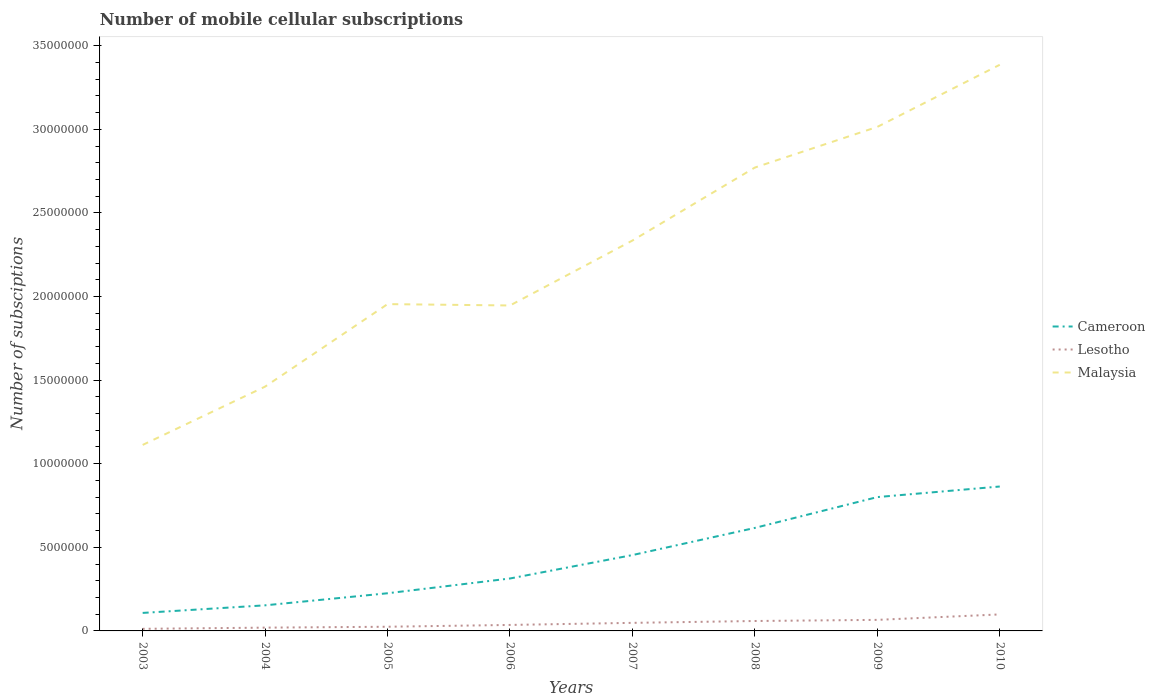How many different coloured lines are there?
Offer a very short reply. 3. Does the line corresponding to Malaysia intersect with the line corresponding to Lesotho?
Your response must be concise. No. Across all years, what is the maximum number of mobile cellular subscriptions in Lesotho?
Offer a terse response. 1.26e+05. What is the total number of mobile cellular subscriptions in Cameroon in the graph?
Provide a succinct answer. -5.08e+06. What is the difference between the highest and the second highest number of mobile cellular subscriptions in Cameroon?
Keep it short and to the point. 7.56e+06. What is the difference between the highest and the lowest number of mobile cellular subscriptions in Cameroon?
Give a very brief answer. 4. Are the values on the major ticks of Y-axis written in scientific E-notation?
Make the answer very short. No. Does the graph contain any zero values?
Offer a very short reply. No. What is the title of the graph?
Provide a succinct answer. Number of mobile cellular subscriptions. Does "Mongolia" appear as one of the legend labels in the graph?
Make the answer very short. No. What is the label or title of the Y-axis?
Offer a terse response. Number of subsciptions. What is the Number of subsciptions in Cameroon in 2003?
Provide a short and direct response. 1.08e+06. What is the Number of subsciptions of Lesotho in 2003?
Provide a short and direct response. 1.26e+05. What is the Number of subsciptions of Malaysia in 2003?
Give a very brief answer. 1.11e+07. What is the Number of subsciptions in Cameroon in 2004?
Keep it short and to the point. 1.53e+06. What is the Number of subsciptions in Lesotho in 2004?
Your answer should be compact. 1.96e+05. What is the Number of subsciptions of Malaysia in 2004?
Your answer should be compact. 1.46e+07. What is the Number of subsciptions of Cameroon in 2005?
Give a very brief answer. 2.25e+06. What is the Number of subsciptions in Lesotho in 2005?
Your answer should be very brief. 2.50e+05. What is the Number of subsciptions in Malaysia in 2005?
Make the answer very short. 1.95e+07. What is the Number of subsciptions in Cameroon in 2006?
Provide a short and direct response. 3.14e+06. What is the Number of subsciptions in Lesotho in 2006?
Offer a terse response. 3.58e+05. What is the Number of subsciptions in Malaysia in 2006?
Your answer should be compact. 1.95e+07. What is the Number of subsciptions of Cameroon in 2007?
Offer a terse response. 4.54e+06. What is the Number of subsciptions of Lesotho in 2007?
Your answer should be compact. 4.82e+05. What is the Number of subsciptions in Malaysia in 2007?
Keep it short and to the point. 2.33e+07. What is the Number of subsciptions in Cameroon in 2008?
Give a very brief answer. 6.16e+06. What is the Number of subsciptions of Lesotho in 2008?
Your answer should be compact. 5.93e+05. What is the Number of subsciptions in Malaysia in 2008?
Your answer should be compact. 2.77e+07. What is the Number of subsciptions of Cameroon in 2009?
Your answer should be compact. 8.00e+06. What is the Number of subsciptions of Lesotho in 2009?
Your answer should be compact. 6.61e+05. What is the Number of subsciptions of Malaysia in 2009?
Your answer should be very brief. 3.01e+07. What is the Number of subsciptions in Cameroon in 2010?
Keep it short and to the point. 8.64e+06. What is the Number of subsciptions in Lesotho in 2010?
Your answer should be compact. 9.87e+05. What is the Number of subsciptions of Malaysia in 2010?
Your response must be concise. 3.39e+07. Across all years, what is the maximum Number of subsciptions of Cameroon?
Make the answer very short. 8.64e+06. Across all years, what is the maximum Number of subsciptions in Lesotho?
Your response must be concise. 9.87e+05. Across all years, what is the maximum Number of subsciptions in Malaysia?
Provide a succinct answer. 3.39e+07. Across all years, what is the minimum Number of subsciptions of Cameroon?
Give a very brief answer. 1.08e+06. Across all years, what is the minimum Number of subsciptions in Lesotho?
Your response must be concise. 1.26e+05. Across all years, what is the minimum Number of subsciptions in Malaysia?
Your answer should be very brief. 1.11e+07. What is the total Number of subsciptions in Cameroon in the graph?
Provide a succinct answer. 3.53e+07. What is the total Number of subsciptions of Lesotho in the graph?
Offer a terse response. 3.65e+06. What is the total Number of subsciptions in Malaysia in the graph?
Provide a short and direct response. 1.80e+08. What is the difference between the Number of subsciptions of Cameroon in 2003 and that in 2004?
Ensure brevity in your answer.  -4.54e+05. What is the difference between the Number of subsciptions of Lesotho in 2003 and that in 2004?
Give a very brief answer. -7.03e+04. What is the difference between the Number of subsciptions in Malaysia in 2003 and that in 2004?
Provide a succinct answer. -3.49e+06. What is the difference between the Number of subsciptions of Cameroon in 2003 and that in 2005?
Give a very brief answer. -1.18e+06. What is the difference between the Number of subsciptions in Lesotho in 2003 and that in 2005?
Provide a succinct answer. -1.24e+05. What is the difference between the Number of subsciptions in Malaysia in 2003 and that in 2005?
Your answer should be very brief. -8.42e+06. What is the difference between the Number of subsciptions in Cameroon in 2003 and that in 2006?
Keep it short and to the point. -2.06e+06. What is the difference between the Number of subsciptions in Lesotho in 2003 and that in 2006?
Your answer should be compact. -2.32e+05. What is the difference between the Number of subsciptions of Malaysia in 2003 and that in 2006?
Keep it short and to the point. -8.34e+06. What is the difference between the Number of subsciptions of Cameroon in 2003 and that in 2007?
Your answer should be compact. -3.46e+06. What is the difference between the Number of subsciptions of Lesotho in 2003 and that in 2007?
Ensure brevity in your answer.  -3.57e+05. What is the difference between the Number of subsciptions of Malaysia in 2003 and that in 2007?
Make the answer very short. -1.22e+07. What is the difference between the Number of subsciptions in Cameroon in 2003 and that in 2008?
Give a very brief answer. -5.08e+06. What is the difference between the Number of subsciptions in Lesotho in 2003 and that in 2008?
Ensure brevity in your answer.  -4.67e+05. What is the difference between the Number of subsciptions in Malaysia in 2003 and that in 2008?
Your answer should be compact. -1.66e+07. What is the difference between the Number of subsciptions of Cameroon in 2003 and that in 2009?
Your answer should be very brief. -6.93e+06. What is the difference between the Number of subsciptions in Lesotho in 2003 and that in 2009?
Give a very brief answer. -5.35e+05. What is the difference between the Number of subsciptions of Malaysia in 2003 and that in 2009?
Offer a terse response. -1.90e+07. What is the difference between the Number of subsciptions of Cameroon in 2003 and that in 2010?
Your response must be concise. -7.56e+06. What is the difference between the Number of subsciptions of Lesotho in 2003 and that in 2010?
Ensure brevity in your answer.  -8.61e+05. What is the difference between the Number of subsciptions of Malaysia in 2003 and that in 2010?
Provide a succinct answer. -2.27e+07. What is the difference between the Number of subsciptions in Cameroon in 2004 and that in 2005?
Ensure brevity in your answer.  -7.22e+05. What is the difference between the Number of subsciptions in Lesotho in 2004 and that in 2005?
Keep it short and to the point. -5.36e+04. What is the difference between the Number of subsciptions of Malaysia in 2004 and that in 2005?
Your answer should be compact. -4.93e+06. What is the difference between the Number of subsciptions in Cameroon in 2004 and that in 2006?
Offer a very short reply. -1.61e+06. What is the difference between the Number of subsciptions in Lesotho in 2004 and that in 2006?
Provide a succinct answer. -1.62e+05. What is the difference between the Number of subsciptions of Malaysia in 2004 and that in 2006?
Offer a terse response. -4.85e+06. What is the difference between the Number of subsciptions in Cameroon in 2004 and that in 2007?
Your answer should be compact. -3.01e+06. What is the difference between the Number of subsciptions of Lesotho in 2004 and that in 2007?
Keep it short and to the point. -2.86e+05. What is the difference between the Number of subsciptions of Malaysia in 2004 and that in 2007?
Your answer should be very brief. -8.74e+06. What is the difference between the Number of subsciptions of Cameroon in 2004 and that in 2008?
Give a very brief answer. -4.63e+06. What is the difference between the Number of subsciptions of Lesotho in 2004 and that in 2008?
Your response must be concise. -3.97e+05. What is the difference between the Number of subsciptions of Malaysia in 2004 and that in 2008?
Your response must be concise. -1.31e+07. What is the difference between the Number of subsciptions of Cameroon in 2004 and that in 2009?
Your response must be concise. -6.47e+06. What is the difference between the Number of subsciptions of Lesotho in 2004 and that in 2009?
Provide a short and direct response. -4.65e+05. What is the difference between the Number of subsciptions in Malaysia in 2004 and that in 2009?
Offer a very short reply. -1.55e+07. What is the difference between the Number of subsciptions of Cameroon in 2004 and that in 2010?
Provide a succinct answer. -7.11e+06. What is the difference between the Number of subsciptions in Lesotho in 2004 and that in 2010?
Offer a very short reply. -7.91e+05. What is the difference between the Number of subsciptions in Malaysia in 2004 and that in 2010?
Keep it short and to the point. -1.92e+07. What is the difference between the Number of subsciptions of Cameroon in 2005 and that in 2006?
Your answer should be very brief. -8.83e+05. What is the difference between the Number of subsciptions in Lesotho in 2005 and that in 2006?
Provide a succinct answer. -1.08e+05. What is the difference between the Number of subsciptions in Malaysia in 2005 and that in 2006?
Offer a terse response. 8.13e+04. What is the difference between the Number of subsciptions in Cameroon in 2005 and that in 2007?
Keep it short and to the point. -2.28e+06. What is the difference between the Number of subsciptions in Lesotho in 2005 and that in 2007?
Your answer should be compact. -2.33e+05. What is the difference between the Number of subsciptions in Malaysia in 2005 and that in 2007?
Your answer should be compact. -3.80e+06. What is the difference between the Number of subsciptions of Cameroon in 2005 and that in 2008?
Your answer should be very brief. -3.91e+06. What is the difference between the Number of subsciptions of Lesotho in 2005 and that in 2008?
Ensure brevity in your answer.  -3.43e+05. What is the difference between the Number of subsciptions in Malaysia in 2005 and that in 2008?
Provide a short and direct response. -8.17e+06. What is the difference between the Number of subsciptions of Cameroon in 2005 and that in 2009?
Provide a short and direct response. -5.75e+06. What is the difference between the Number of subsciptions of Lesotho in 2005 and that in 2009?
Provide a succinct answer. -4.11e+05. What is the difference between the Number of subsciptions of Malaysia in 2005 and that in 2009?
Provide a short and direct response. -1.06e+07. What is the difference between the Number of subsciptions of Cameroon in 2005 and that in 2010?
Ensure brevity in your answer.  -6.38e+06. What is the difference between the Number of subsciptions of Lesotho in 2005 and that in 2010?
Make the answer very short. -7.38e+05. What is the difference between the Number of subsciptions of Malaysia in 2005 and that in 2010?
Your answer should be compact. -1.43e+07. What is the difference between the Number of subsciptions of Cameroon in 2006 and that in 2007?
Give a very brief answer. -1.40e+06. What is the difference between the Number of subsciptions in Lesotho in 2006 and that in 2007?
Provide a short and direct response. -1.25e+05. What is the difference between the Number of subsciptions of Malaysia in 2006 and that in 2007?
Keep it short and to the point. -3.88e+06. What is the difference between the Number of subsciptions in Cameroon in 2006 and that in 2008?
Ensure brevity in your answer.  -3.02e+06. What is the difference between the Number of subsciptions of Lesotho in 2006 and that in 2008?
Make the answer very short. -2.35e+05. What is the difference between the Number of subsciptions in Malaysia in 2006 and that in 2008?
Make the answer very short. -8.25e+06. What is the difference between the Number of subsciptions of Cameroon in 2006 and that in 2009?
Offer a terse response. -4.87e+06. What is the difference between the Number of subsciptions in Lesotho in 2006 and that in 2009?
Your response must be concise. -3.03e+05. What is the difference between the Number of subsciptions of Malaysia in 2006 and that in 2009?
Offer a terse response. -1.07e+07. What is the difference between the Number of subsciptions in Cameroon in 2006 and that in 2010?
Your answer should be compact. -5.50e+06. What is the difference between the Number of subsciptions of Lesotho in 2006 and that in 2010?
Offer a terse response. -6.30e+05. What is the difference between the Number of subsciptions in Malaysia in 2006 and that in 2010?
Your response must be concise. -1.44e+07. What is the difference between the Number of subsciptions of Cameroon in 2007 and that in 2008?
Offer a terse response. -1.62e+06. What is the difference between the Number of subsciptions of Lesotho in 2007 and that in 2008?
Your answer should be very brief. -1.11e+05. What is the difference between the Number of subsciptions of Malaysia in 2007 and that in 2008?
Offer a terse response. -4.37e+06. What is the difference between the Number of subsciptions in Cameroon in 2007 and that in 2009?
Offer a very short reply. -3.47e+06. What is the difference between the Number of subsciptions of Lesotho in 2007 and that in 2009?
Your answer should be compact. -1.79e+05. What is the difference between the Number of subsciptions of Malaysia in 2007 and that in 2009?
Your answer should be compact. -6.80e+06. What is the difference between the Number of subsciptions in Cameroon in 2007 and that in 2010?
Your answer should be compact. -4.10e+06. What is the difference between the Number of subsciptions in Lesotho in 2007 and that in 2010?
Make the answer very short. -5.05e+05. What is the difference between the Number of subsciptions of Malaysia in 2007 and that in 2010?
Keep it short and to the point. -1.05e+07. What is the difference between the Number of subsciptions of Cameroon in 2008 and that in 2009?
Offer a very short reply. -1.84e+06. What is the difference between the Number of subsciptions of Lesotho in 2008 and that in 2009?
Make the answer very short. -6.78e+04. What is the difference between the Number of subsciptions of Malaysia in 2008 and that in 2009?
Ensure brevity in your answer.  -2.43e+06. What is the difference between the Number of subsciptions in Cameroon in 2008 and that in 2010?
Your answer should be very brief. -2.48e+06. What is the difference between the Number of subsciptions of Lesotho in 2008 and that in 2010?
Your answer should be very brief. -3.94e+05. What is the difference between the Number of subsciptions in Malaysia in 2008 and that in 2010?
Make the answer very short. -6.15e+06. What is the difference between the Number of subsciptions in Cameroon in 2009 and that in 2010?
Offer a terse response. -6.33e+05. What is the difference between the Number of subsciptions of Lesotho in 2009 and that in 2010?
Keep it short and to the point. -3.26e+05. What is the difference between the Number of subsciptions of Malaysia in 2009 and that in 2010?
Your answer should be very brief. -3.71e+06. What is the difference between the Number of subsciptions in Cameroon in 2003 and the Number of subsciptions in Lesotho in 2004?
Your response must be concise. 8.81e+05. What is the difference between the Number of subsciptions of Cameroon in 2003 and the Number of subsciptions of Malaysia in 2004?
Give a very brief answer. -1.35e+07. What is the difference between the Number of subsciptions of Lesotho in 2003 and the Number of subsciptions of Malaysia in 2004?
Offer a very short reply. -1.45e+07. What is the difference between the Number of subsciptions in Cameroon in 2003 and the Number of subsciptions in Lesotho in 2005?
Ensure brevity in your answer.  8.27e+05. What is the difference between the Number of subsciptions of Cameroon in 2003 and the Number of subsciptions of Malaysia in 2005?
Ensure brevity in your answer.  -1.85e+07. What is the difference between the Number of subsciptions in Lesotho in 2003 and the Number of subsciptions in Malaysia in 2005?
Make the answer very short. -1.94e+07. What is the difference between the Number of subsciptions in Cameroon in 2003 and the Number of subsciptions in Lesotho in 2006?
Your answer should be very brief. 7.19e+05. What is the difference between the Number of subsciptions in Cameroon in 2003 and the Number of subsciptions in Malaysia in 2006?
Ensure brevity in your answer.  -1.84e+07. What is the difference between the Number of subsciptions of Lesotho in 2003 and the Number of subsciptions of Malaysia in 2006?
Offer a terse response. -1.93e+07. What is the difference between the Number of subsciptions of Cameroon in 2003 and the Number of subsciptions of Lesotho in 2007?
Give a very brief answer. 5.95e+05. What is the difference between the Number of subsciptions of Cameroon in 2003 and the Number of subsciptions of Malaysia in 2007?
Offer a very short reply. -2.23e+07. What is the difference between the Number of subsciptions in Lesotho in 2003 and the Number of subsciptions in Malaysia in 2007?
Offer a very short reply. -2.32e+07. What is the difference between the Number of subsciptions in Cameroon in 2003 and the Number of subsciptions in Lesotho in 2008?
Keep it short and to the point. 4.84e+05. What is the difference between the Number of subsciptions in Cameroon in 2003 and the Number of subsciptions in Malaysia in 2008?
Your answer should be very brief. -2.66e+07. What is the difference between the Number of subsciptions of Lesotho in 2003 and the Number of subsciptions of Malaysia in 2008?
Your answer should be compact. -2.76e+07. What is the difference between the Number of subsciptions of Cameroon in 2003 and the Number of subsciptions of Lesotho in 2009?
Ensure brevity in your answer.  4.16e+05. What is the difference between the Number of subsciptions of Cameroon in 2003 and the Number of subsciptions of Malaysia in 2009?
Your answer should be compact. -2.91e+07. What is the difference between the Number of subsciptions in Lesotho in 2003 and the Number of subsciptions in Malaysia in 2009?
Your answer should be compact. -3.00e+07. What is the difference between the Number of subsciptions in Cameroon in 2003 and the Number of subsciptions in Lesotho in 2010?
Give a very brief answer. 8.96e+04. What is the difference between the Number of subsciptions in Cameroon in 2003 and the Number of subsciptions in Malaysia in 2010?
Make the answer very short. -3.28e+07. What is the difference between the Number of subsciptions of Lesotho in 2003 and the Number of subsciptions of Malaysia in 2010?
Make the answer very short. -3.37e+07. What is the difference between the Number of subsciptions of Cameroon in 2004 and the Number of subsciptions of Lesotho in 2005?
Provide a succinct answer. 1.28e+06. What is the difference between the Number of subsciptions of Cameroon in 2004 and the Number of subsciptions of Malaysia in 2005?
Provide a succinct answer. -1.80e+07. What is the difference between the Number of subsciptions of Lesotho in 2004 and the Number of subsciptions of Malaysia in 2005?
Ensure brevity in your answer.  -1.93e+07. What is the difference between the Number of subsciptions in Cameroon in 2004 and the Number of subsciptions in Lesotho in 2006?
Provide a succinct answer. 1.17e+06. What is the difference between the Number of subsciptions in Cameroon in 2004 and the Number of subsciptions in Malaysia in 2006?
Make the answer very short. -1.79e+07. What is the difference between the Number of subsciptions of Lesotho in 2004 and the Number of subsciptions of Malaysia in 2006?
Make the answer very short. -1.93e+07. What is the difference between the Number of subsciptions in Cameroon in 2004 and the Number of subsciptions in Lesotho in 2007?
Your answer should be compact. 1.05e+06. What is the difference between the Number of subsciptions of Cameroon in 2004 and the Number of subsciptions of Malaysia in 2007?
Keep it short and to the point. -2.18e+07. What is the difference between the Number of subsciptions in Lesotho in 2004 and the Number of subsciptions in Malaysia in 2007?
Provide a short and direct response. -2.32e+07. What is the difference between the Number of subsciptions in Cameroon in 2004 and the Number of subsciptions in Lesotho in 2008?
Provide a succinct answer. 9.38e+05. What is the difference between the Number of subsciptions of Cameroon in 2004 and the Number of subsciptions of Malaysia in 2008?
Offer a very short reply. -2.62e+07. What is the difference between the Number of subsciptions in Lesotho in 2004 and the Number of subsciptions in Malaysia in 2008?
Your response must be concise. -2.75e+07. What is the difference between the Number of subsciptions of Cameroon in 2004 and the Number of subsciptions of Lesotho in 2009?
Provide a succinct answer. 8.70e+05. What is the difference between the Number of subsciptions of Cameroon in 2004 and the Number of subsciptions of Malaysia in 2009?
Keep it short and to the point. -2.86e+07. What is the difference between the Number of subsciptions of Lesotho in 2004 and the Number of subsciptions of Malaysia in 2009?
Provide a succinct answer. -2.99e+07. What is the difference between the Number of subsciptions of Cameroon in 2004 and the Number of subsciptions of Lesotho in 2010?
Keep it short and to the point. 5.43e+05. What is the difference between the Number of subsciptions in Cameroon in 2004 and the Number of subsciptions in Malaysia in 2010?
Keep it short and to the point. -3.23e+07. What is the difference between the Number of subsciptions of Lesotho in 2004 and the Number of subsciptions of Malaysia in 2010?
Offer a terse response. -3.37e+07. What is the difference between the Number of subsciptions of Cameroon in 2005 and the Number of subsciptions of Lesotho in 2006?
Your response must be concise. 1.89e+06. What is the difference between the Number of subsciptions in Cameroon in 2005 and the Number of subsciptions in Malaysia in 2006?
Ensure brevity in your answer.  -1.72e+07. What is the difference between the Number of subsciptions of Lesotho in 2005 and the Number of subsciptions of Malaysia in 2006?
Make the answer very short. -1.92e+07. What is the difference between the Number of subsciptions in Cameroon in 2005 and the Number of subsciptions in Lesotho in 2007?
Keep it short and to the point. 1.77e+06. What is the difference between the Number of subsciptions in Cameroon in 2005 and the Number of subsciptions in Malaysia in 2007?
Provide a succinct answer. -2.11e+07. What is the difference between the Number of subsciptions of Lesotho in 2005 and the Number of subsciptions of Malaysia in 2007?
Offer a very short reply. -2.31e+07. What is the difference between the Number of subsciptions in Cameroon in 2005 and the Number of subsciptions in Lesotho in 2008?
Provide a short and direct response. 1.66e+06. What is the difference between the Number of subsciptions of Cameroon in 2005 and the Number of subsciptions of Malaysia in 2008?
Your answer should be very brief. -2.55e+07. What is the difference between the Number of subsciptions in Lesotho in 2005 and the Number of subsciptions in Malaysia in 2008?
Your response must be concise. -2.75e+07. What is the difference between the Number of subsciptions in Cameroon in 2005 and the Number of subsciptions in Lesotho in 2009?
Provide a succinct answer. 1.59e+06. What is the difference between the Number of subsciptions in Cameroon in 2005 and the Number of subsciptions in Malaysia in 2009?
Offer a terse response. -2.79e+07. What is the difference between the Number of subsciptions in Lesotho in 2005 and the Number of subsciptions in Malaysia in 2009?
Your answer should be compact. -2.99e+07. What is the difference between the Number of subsciptions in Cameroon in 2005 and the Number of subsciptions in Lesotho in 2010?
Your answer should be compact. 1.27e+06. What is the difference between the Number of subsciptions in Cameroon in 2005 and the Number of subsciptions in Malaysia in 2010?
Give a very brief answer. -3.16e+07. What is the difference between the Number of subsciptions in Lesotho in 2005 and the Number of subsciptions in Malaysia in 2010?
Offer a very short reply. -3.36e+07. What is the difference between the Number of subsciptions in Cameroon in 2006 and the Number of subsciptions in Lesotho in 2007?
Provide a short and direct response. 2.65e+06. What is the difference between the Number of subsciptions in Cameroon in 2006 and the Number of subsciptions in Malaysia in 2007?
Your response must be concise. -2.02e+07. What is the difference between the Number of subsciptions of Lesotho in 2006 and the Number of subsciptions of Malaysia in 2007?
Provide a short and direct response. -2.30e+07. What is the difference between the Number of subsciptions of Cameroon in 2006 and the Number of subsciptions of Lesotho in 2008?
Offer a very short reply. 2.54e+06. What is the difference between the Number of subsciptions in Cameroon in 2006 and the Number of subsciptions in Malaysia in 2008?
Make the answer very short. -2.46e+07. What is the difference between the Number of subsciptions in Lesotho in 2006 and the Number of subsciptions in Malaysia in 2008?
Your answer should be very brief. -2.74e+07. What is the difference between the Number of subsciptions of Cameroon in 2006 and the Number of subsciptions of Lesotho in 2009?
Give a very brief answer. 2.47e+06. What is the difference between the Number of subsciptions in Cameroon in 2006 and the Number of subsciptions in Malaysia in 2009?
Provide a short and direct response. -2.70e+07. What is the difference between the Number of subsciptions in Lesotho in 2006 and the Number of subsciptions in Malaysia in 2009?
Ensure brevity in your answer.  -2.98e+07. What is the difference between the Number of subsciptions of Cameroon in 2006 and the Number of subsciptions of Lesotho in 2010?
Offer a very short reply. 2.15e+06. What is the difference between the Number of subsciptions in Cameroon in 2006 and the Number of subsciptions in Malaysia in 2010?
Give a very brief answer. -3.07e+07. What is the difference between the Number of subsciptions in Lesotho in 2006 and the Number of subsciptions in Malaysia in 2010?
Offer a terse response. -3.35e+07. What is the difference between the Number of subsciptions of Cameroon in 2007 and the Number of subsciptions of Lesotho in 2008?
Provide a short and direct response. 3.94e+06. What is the difference between the Number of subsciptions in Cameroon in 2007 and the Number of subsciptions in Malaysia in 2008?
Your answer should be very brief. -2.32e+07. What is the difference between the Number of subsciptions in Lesotho in 2007 and the Number of subsciptions in Malaysia in 2008?
Give a very brief answer. -2.72e+07. What is the difference between the Number of subsciptions in Cameroon in 2007 and the Number of subsciptions in Lesotho in 2009?
Keep it short and to the point. 3.88e+06. What is the difference between the Number of subsciptions in Cameroon in 2007 and the Number of subsciptions in Malaysia in 2009?
Your response must be concise. -2.56e+07. What is the difference between the Number of subsciptions in Lesotho in 2007 and the Number of subsciptions in Malaysia in 2009?
Give a very brief answer. -2.97e+07. What is the difference between the Number of subsciptions of Cameroon in 2007 and the Number of subsciptions of Lesotho in 2010?
Make the answer very short. 3.55e+06. What is the difference between the Number of subsciptions of Cameroon in 2007 and the Number of subsciptions of Malaysia in 2010?
Your answer should be compact. -2.93e+07. What is the difference between the Number of subsciptions in Lesotho in 2007 and the Number of subsciptions in Malaysia in 2010?
Ensure brevity in your answer.  -3.34e+07. What is the difference between the Number of subsciptions of Cameroon in 2008 and the Number of subsciptions of Lesotho in 2009?
Offer a terse response. 5.50e+06. What is the difference between the Number of subsciptions of Cameroon in 2008 and the Number of subsciptions of Malaysia in 2009?
Provide a short and direct response. -2.40e+07. What is the difference between the Number of subsciptions of Lesotho in 2008 and the Number of subsciptions of Malaysia in 2009?
Your response must be concise. -2.96e+07. What is the difference between the Number of subsciptions of Cameroon in 2008 and the Number of subsciptions of Lesotho in 2010?
Your answer should be very brief. 5.17e+06. What is the difference between the Number of subsciptions of Cameroon in 2008 and the Number of subsciptions of Malaysia in 2010?
Your response must be concise. -2.77e+07. What is the difference between the Number of subsciptions in Lesotho in 2008 and the Number of subsciptions in Malaysia in 2010?
Provide a short and direct response. -3.33e+07. What is the difference between the Number of subsciptions of Cameroon in 2009 and the Number of subsciptions of Lesotho in 2010?
Your answer should be very brief. 7.02e+06. What is the difference between the Number of subsciptions in Cameroon in 2009 and the Number of subsciptions in Malaysia in 2010?
Provide a succinct answer. -2.59e+07. What is the difference between the Number of subsciptions in Lesotho in 2009 and the Number of subsciptions in Malaysia in 2010?
Keep it short and to the point. -3.32e+07. What is the average Number of subsciptions of Cameroon per year?
Your answer should be compact. 4.42e+06. What is the average Number of subsciptions in Lesotho per year?
Provide a short and direct response. 4.57e+05. What is the average Number of subsciptions of Malaysia per year?
Ensure brevity in your answer.  2.25e+07. In the year 2003, what is the difference between the Number of subsciptions of Cameroon and Number of subsciptions of Lesotho?
Offer a very short reply. 9.51e+05. In the year 2003, what is the difference between the Number of subsciptions of Cameroon and Number of subsciptions of Malaysia?
Your answer should be very brief. -1.00e+07. In the year 2003, what is the difference between the Number of subsciptions of Lesotho and Number of subsciptions of Malaysia?
Your answer should be very brief. -1.10e+07. In the year 2004, what is the difference between the Number of subsciptions of Cameroon and Number of subsciptions of Lesotho?
Provide a short and direct response. 1.33e+06. In the year 2004, what is the difference between the Number of subsciptions of Cameroon and Number of subsciptions of Malaysia?
Give a very brief answer. -1.31e+07. In the year 2004, what is the difference between the Number of subsciptions in Lesotho and Number of subsciptions in Malaysia?
Provide a succinct answer. -1.44e+07. In the year 2005, what is the difference between the Number of subsciptions of Cameroon and Number of subsciptions of Lesotho?
Provide a succinct answer. 2.00e+06. In the year 2005, what is the difference between the Number of subsciptions in Cameroon and Number of subsciptions in Malaysia?
Provide a short and direct response. -1.73e+07. In the year 2005, what is the difference between the Number of subsciptions in Lesotho and Number of subsciptions in Malaysia?
Keep it short and to the point. -1.93e+07. In the year 2006, what is the difference between the Number of subsciptions of Cameroon and Number of subsciptions of Lesotho?
Offer a terse response. 2.78e+06. In the year 2006, what is the difference between the Number of subsciptions of Cameroon and Number of subsciptions of Malaysia?
Offer a terse response. -1.63e+07. In the year 2006, what is the difference between the Number of subsciptions of Lesotho and Number of subsciptions of Malaysia?
Make the answer very short. -1.91e+07. In the year 2007, what is the difference between the Number of subsciptions in Cameroon and Number of subsciptions in Lesotho?
Offer a terse response. 4.05e+06. In the year 2007, what is the difference between the Number of subsciptions of Cameroon and Number of subsciptions of Malaysia?
Make the answer very short. -1.88e+07. In the year 2007, what is the difference between the Number of subsciptions in Lesotho and Number of subsciptions in Malaysia?
Your answer should be very brief. -2.29e+07. In the year 2008, what is the difference between the Number of subsciptions of Cameroon and Number of subsciptions of Lesotho?
Offer a very short reply. 5.57e+06. In the year 2008, what is the difference between the Number of subsciptions of Cameroon and Number of subsciptions of Malaysia?
Ensure brevity in your answer.  -2.16e+07. In the year 2008, what is the difference between the Number of subsciptions of Lesotho and Number of subsciptions of Malaysia?
Provide a short and direct response. -2.71e+07. In the year 2009, what is the difference between the Number of subsciptions of Cameroon and Number of subsciptions of Lesotho?
Provide a succinct answer. 7.34e+06. In the year 2009, what is the difference between the Number of subsciptions of Cameroon and Number of subsciptions of Malaysia?
Your answer should be compact. -2.21e+07. In the year 2009, what is the difference between the Number of subsciptions in Lesotho and Number of subsciptions in Malaysia?
Give a very brief answer. -2.95e+07. In the year 2010, what is the difference between the Number of subsciptions of Cameroon and Number of subsciptions of Lesotho?
Offer a very short reply. 7.65e+06. In the year 2010, what is the difference between the Number of subsciptions of Cameroon and Number of subsciptions of Malaysia?
Provide a succinct answer. -2.52e+07. In the year 2010, what is the difference between the Number of subsciptions in Lesotho and Number of subsciptions in Malaysia?
Make the answer very short. -3.29e+07. What is the ratio of the Number of subsciptions in Cameroon in 2003 to that in 2004?
Keep it short and to the point. 0.7. What is the ratio of the Number of subsciptions in Lesotho in 2003 to that in 2004?
Your response must be concise. 0.64. What is the ratio of the Number of subsciptions of Malaysia in 2003 to that in 2004?
Make the answer very short. 0.76. What is the ratio of the Number of subsciptions in Cameroon in 2003 to that in 2005?
Give a very brief answer. 0.48. What is the ratio of the Number of subsciptions in Lesotho in 2003 to that in 2005?
Give a very brief answer. 0.5. What is the ratio of the Number of subsciptions of Malaysia in 2003 to that in 2005?
Provide a succinct answer. 0.57. What is the ratio of the Number of subsciptions in Cameroon in 2003 to that in 2006?
Your answer should be very brief. 0.34. What is the ratio of the Number of subsciptions of Lesotho in 2003 to that in 2006?
Provide a short and direct response. 0.35. What is the ratio of the Number of subsciptions of Malaysia in 2003 to that in 2006?
Keep it short and to the point. 0.57. What is the ratio of the Number of subsciptions in Cameroon in 2003 to that in 2007?
Provide a short and direct response. 0.24. What is the ratio of the Number of subsciptions of Lesotho in 2003 to that in 2007?
Provide a short and direct response. 0.26. What is the ratio of the Number of subsciptions of Malaysia in 2003 to that in 2007?
Ensure brevity in your answer.  0.48. What is the ratio of the Number of subsciptions in Cameroon in 2003 to that in 2008?
Provide a short and direct response. 0.17. What is the ratio of the Number of subsciptions of Lesotho in 2003 to that in 2008?
Keep it short and to the point. 0.21. What is the ratio of the Number of subsciptions of Malaysia in 2003 to that in 2008?
Your answer should be compact. 0.4. What is the ratio of the Number of subsciptions in Cameroon in 2003 to that in 2009?
Ensure brevity in your answer.  0.13. What is the ratio of the Number of subsciptions of Lesotho in 2003 to that in 2009?
Offer a terse response. 0.19. What is the ratio of the Number of subsciptions in Malaysia in 2003 to that in 2009?
Ensure brevity in your answer.  0.37. What is the ratio of the Number of subsciptions of Cameroon in 2003 to that in 2010?
Offer a very short reply. 0.12. What is the ratio of the Number of subsciptions in Lesotho in 2003 to that in 2010?
Provide a short and direct response. 0.13. What is the ratio of the Number of subsciptions in Malaysia in 2003 to that in 2010?
Your answer should be very brief. 0.33. What is the ratio of the Number of subsciptions in Cameroon in 2004 to that in 2005?
Your response must be concise. 0.68. What is the ratio of the Number of subsciptions in Lesotho in 2004 to that in 2005?
Ensure brevity in your answer.  0.79. What is the ratio of the Number of subsciptions in Malaysia in 2004 to that in 2005?
Keep it short and to the point. 0.75. What is the ratio of the Number of subsciptions in Cameroon in 2004 to that in 2006?
Keep it short and to the point. 0.49. What is the ratio of the Number of subsciptions in Lesotho in 2004 to that in 2006?
Offer a very short reply. 0.55. What is the ratio of the Number of subsciptions in Malaysia in 2004 to that in 2006?
Provide a succinct answer. 0.75. What is the ratio of the Number of subsciptions in Cameroon in 2004 to that in 2007?
Provide a succinct answer. 0.34. What is the ratio of the Number of subsciptions in Lesotho in 2004 to that in 2007?
Provide a short and direct response. 0.41. What is the ratio of the Number of subsciptions of Malaysia in 2004 to that in 2007?
Give a very brief answer. 0.63. What is the ratio of the Number of subsciptions of Cameroon in 2004 to that in 2008?
Ensure brevity in your answer.  0.25. What is the ratio of the Number of subsciptions of Lesotho in 2004 to that in 2008?
Offer a terse response. 0.33. What is the ratio of the Number of subsciptions in Malaysia in 2004 to that in 2008?
Ensure brevity in your answer.  0.53. What is the ratio of the Number of subsciptions of Cameroon in 2004 to that in 2009?
Offer a terse response. 0.19. What is the ratio of the Number of subsciptions of Lesotho in 2004 to that in 2009?
Offer a terse response. 0.3. What is the ratio of the Number of subsciptions in Malaysia in 2004 to that in 2009?
Offer a very short reply. 0.48. What is the ratio of the Number of subsciptions in Cameroon in 2004 to that in 2010?
Ensure brevity in your answer.  0.18. What is the ratio of the Number of subsciptions of Lesotho in 2004 to that in 2010?
Your answer should be very brief. 0.2. What is the ratio of the Number of subsciptions of Malaysia in 2004 to that in 2010?
Your response must be concise. 0.43. What is the ratio of the Number of subsciptions of Cameroon in 2005 to that in 2006?
Keep it short and to the point. 0.72. What is the ratio of the Number of subsciptions of Lesotho in 2005 to that in 2006?
Give a very brief answer. 0.7. What is the ratio of the Number of subsciptions of Malaysia in 2005 to that in 2006?
Provide a succinct answer. 1. What is the ratio of the Number of subsciptions in Cameroon in 2005 to that in 2007?
Make the answer very short. 0.5. What is the ratio of the Number of subsciptions in Lesotho in 2005 to that in 2007?
Your answer should be compact. 0.52. What is the ratio of the Number of subsciptions in Malaysia in 2005 to that in 2007?
Your answer should be very brief. 0.84. What is the ratio of the Number of subsciptions of Cameroon in 2005 to that in 2008?
Offer a terse response. 0.37. What is the ratio of the Number of subsciptions in Lesotho in 2005 to that in 2008?
Your answer should be compact. 0.42. What is the ratio of the Number of subsciptions in Malaysia in 2005 to that in 2008?
Keep it short and to the point. 0.71. What is the ratio of the Number of subsciptions of Cameroon in 2005 to that in 2009?
Your answer should be very brief. 0.28. What is the ratio of the Number of subsciptions in Lesotho in 2005 to that in 2009?
Your response must be concise. 0.38. What is the ratio of the Number of subsciptions in Malaysia in 2005 to that in 2009?
Provide a short and direct response. 0.65. What is the ratio of the Number of subsciptions of Cameroon in 2005 to that in 2010?
Give a very brief answer. 0.26. What is the ratio of the Number of subsciptions of Lesotho in 2005 to that in 2010?
Offer a terse response. 0.25. What is the ratio of the Number of subsciptions in Malaysia in 2005 to that in 2010?
Offer a terse response. 0.58. What is the ratio of the Number of subsciptions in Cameroon in 2006 to that in 2007?
Give a very brief answer. 0.69. What is the ratio of the Number of subsciptions in Lesotho in 2006 to that in 2007?
Your answer should be very brief. 0.74. What is the ratio of the Number of subsciptions of Malaysia in 2006 to that in 2007?
Your answer should be compact. 0.83. What is the ratio of the Number of subsciptions of Cameroon in 2006 to that in 2008?
Provide a succinct answer. 0.51. What is the ratio of the Number of subsciptions of Lesotho in 2006 to that in 2008?
Your answer should be very brief. 0.6. What is the ratio of the Number of subsciptions in Malaysia in 2006 to that in 2008?
Give a very brief answer. 0.7. What is the ratio of the Number of subsciptions of Cameroon in 2006 to that in 2009?
Make the answer very short. 0.39. What is the ratio of the Number of subsciptions of Lesotho in 2006 to that in 2009?
Keep it short and to the point. 0.54. What is the ratio of the Number of subsciptions of Malaysia in 2006 to that in 2009?
Keep it short and to the point. 0.65. What is the ratio of the Number of subsciptions of Cameroon in 2006 to that in 2010?
Offer a terse response. 0.36. What is the ratio of the Number of subsciptions in Lesotho in 2006 to that in 2010?
Ensure brevity in your answer.  0.36. What is the ratio of the Number of subsciptions in Malaysia in 2006 to that in 2010?
Make the answer very short. 0.57. What is the ratio of the Number of subsciptions of Cameroon in 2007 to that in 2008?
Ensure brevity in your answer.  0.74. What is the ratio of the Number of subsciptions of Lesotho in 2007 to that in 2008?
Make the answer very short. 0.81. What is the ratio of the Number of subsciptions in Malaysia in 2007 to that in 2008?
Provide a succinct answer. 0.84. What is the ratio of the Number of subsciptions of Cameroon in 2007 to that in 2009?
Ensure brevity in your answer.  0.57. What is the ratio of the Number of subsciptions of Lesotho in 2007 to that in 2009?
Give a very brief answer. 0.73. What is the ratio of the Number of subsciptions in Malaysia in 2007 to that in 2009?
Your response must be concise. 0.77. What is the ratio of the Number of subsciptions in Cameroon in 2007 to that in 2010?
Offer a very short reply. 0.53. What is the ratio of the Number of subsciptions in Lesotho in 2007 to that in 2010?
Your answer should be very brief. 0.49. What is the ratio of the Number of subsciptions of Malaysia in 2007 to that in 2010?
Provide a short and direct response. 0.69. What is the ratio of the Number of subsciptions in Cameroon in 2008 to that in 2009?
Your response must be concise. 0.77. What is the ratio of the Number of subsciptions of Lesotho in 2008 to that in 2009?
Provide a short and direct response. 0.9. What is the ratio of the Number of subsciptions in Malaysia in 2008 to that in 2009?
Provide a short and direct response. 0.92. What is the ratio of the Number of subsciptions in Cameroon in 2008 to that in 2010?
Provide a short and direct response. 0.71. What is the ratio of the Number of subsciptions in Lesotho in 2008 to that in 2010?
Offer a very short reply. 0.6. What is the ratio of the Number of subsciptions in Malaysia in 2008 to that in 2010?
Provide a succinct answer. 0.82. What is the ratio of the Number of subsciptions in Cameroon in 2009 to that in 2010?
Ensure brevity in your answer.  0.93. What is the ratio of the Number of subsciptions in Lesotho in 2009 to that in 2010?
Ensure brevity in your answer.  0.67. What is the ratio of the Number of subsciptions in Malaysia in 2009 to that in 2010?
Your answer should be compact. 0.89. What is the difference between the highest and the second highest Number of subsciptions in Cameroon?
Your response must be concise. 6.33e+05. What is the difference between the highest and the second highest Number of subsciptions in Lesotho?
Your answer should be very brief. 3.26e+05. What is the difference between the highest and the second highest Number of subsciptions of Malaysia?
Your response must be concise. 3.71e+06. What is the difference between the highest and the lowest Number of subsciptions in Cameroon?
Offer a terse response. 7.56e+06. What is the difference between the highest and the lowest Number of subsciptions of Lesotho?
Ensure brevity in your answer.  8.61e+05. What is the difference between the highest and the lowest Number of subsciptions of Malaysia?
Offer a terse response. 2.27e+07. 